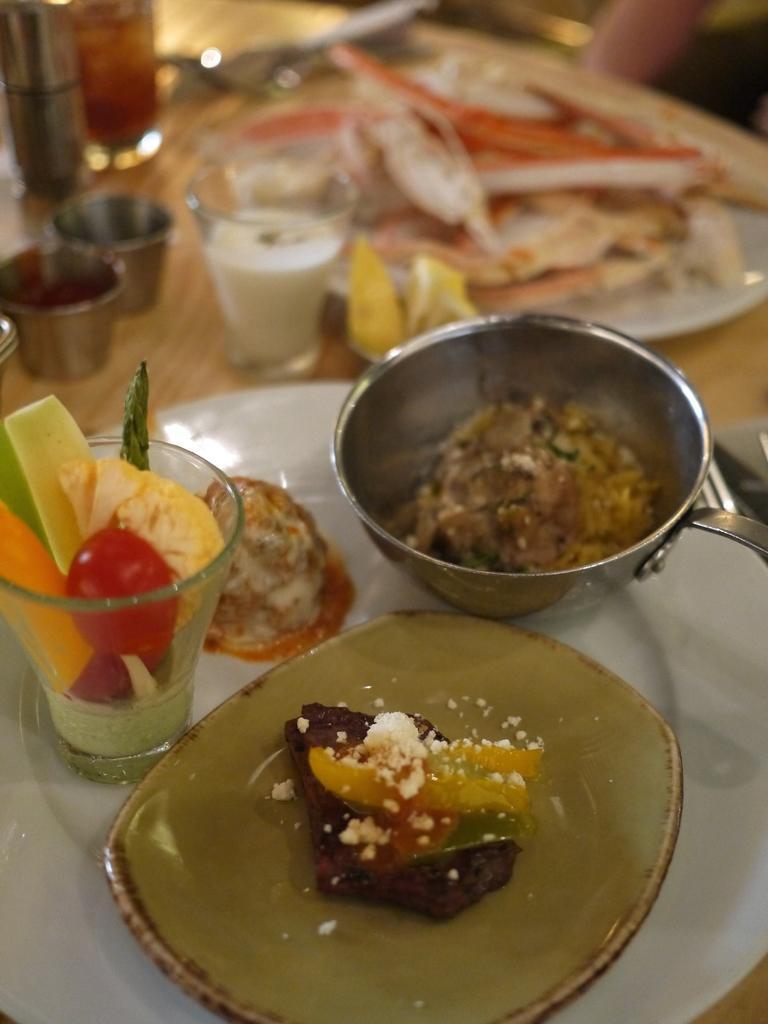Could you give a brief overview of what you see in this image? In this image we can see food items in plate. There are glasses and other objects on the table. 